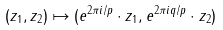<formula> <loc_0><loc_0><loc_500><loc_500>( z _ { 1 } , z _ { 2 } ) \mapsto ( e ^ { 2 \pi i / p } \cdot z _ { 1 } , e ^ { 2 \pi i q / p } \cdot z _ { 2 } )</formula> 